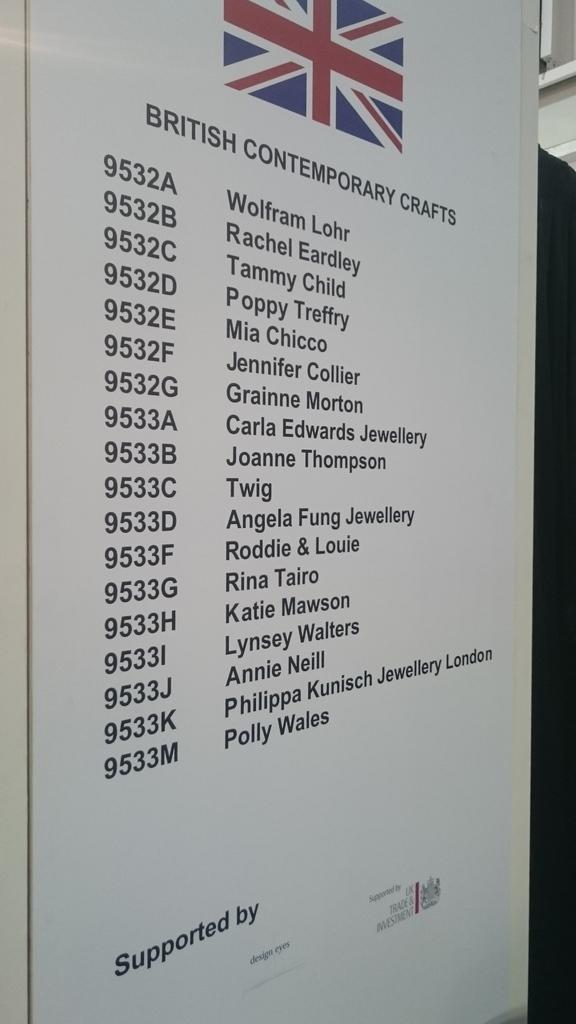<image>
Provide a brief description of the given image. List of british contemporary crafts and names of people 